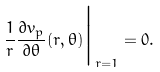<formula> <loc_0><loc_0><loc_500><loc_500>\frac { 1 } { r } \frac { \partial v _ { p } } { \partial \theta } ( r , \theta ) \Big | _ { r = 1 } = 0 .</formula> 